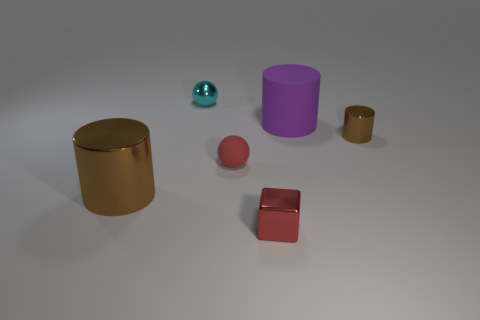Subtract all big cylinders. How many cylinders are left? 1 Add 1 large rubber things. How many objects exist? 7 Subtract all purple cylinders. How many cylinders are left? 2 Subtract 2 cylinders. How many cylinders are left? 1 Subtract all blue cubes. How many brown cylinders are left? 2 Subtract all large brown spheres. Subtract all purple matte things. How many objects are left? 5 Add 1 purple rubber cylinders. How many purple rubber cylinders are left? 2 Add 1 gray rubber balls. How many gray rubber balls exist? 1 Subtract 1 red spheres. How many objects are left? 5 Subtract all cubes. How many objects are left? 5 